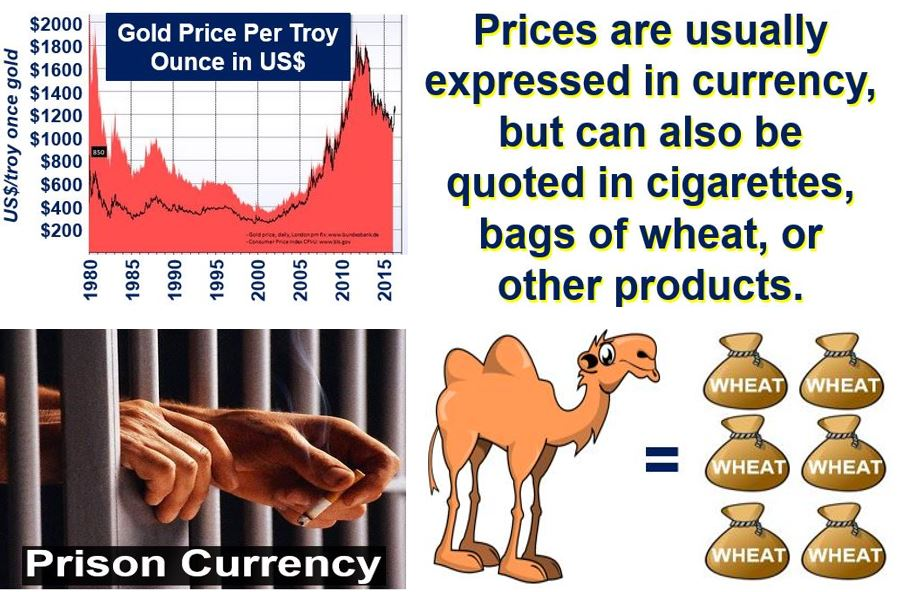Considering the diverse forms of currency illustrated in the image, how might the value of a commodity like wheat change in a prison environment compared to the outside world? While the image doesn’t explicitly detail the value of wheat in a prison environment versus the outside world, it provides important context about alternative forms of currency. In places where traditional money is unavailable or impractical, such as prisons, commodities like wheat may acquire varying values based on demand and scarcity. Typically, high-demand items such as cigarettes become prevalent as informal currency in prison due to their widespread desire and utility. If wheat were obtainable and sought after within the prison, its value might inflate significantly compared to the outside world where monetary exchanges prevail, and wheat is more readily accessible. 